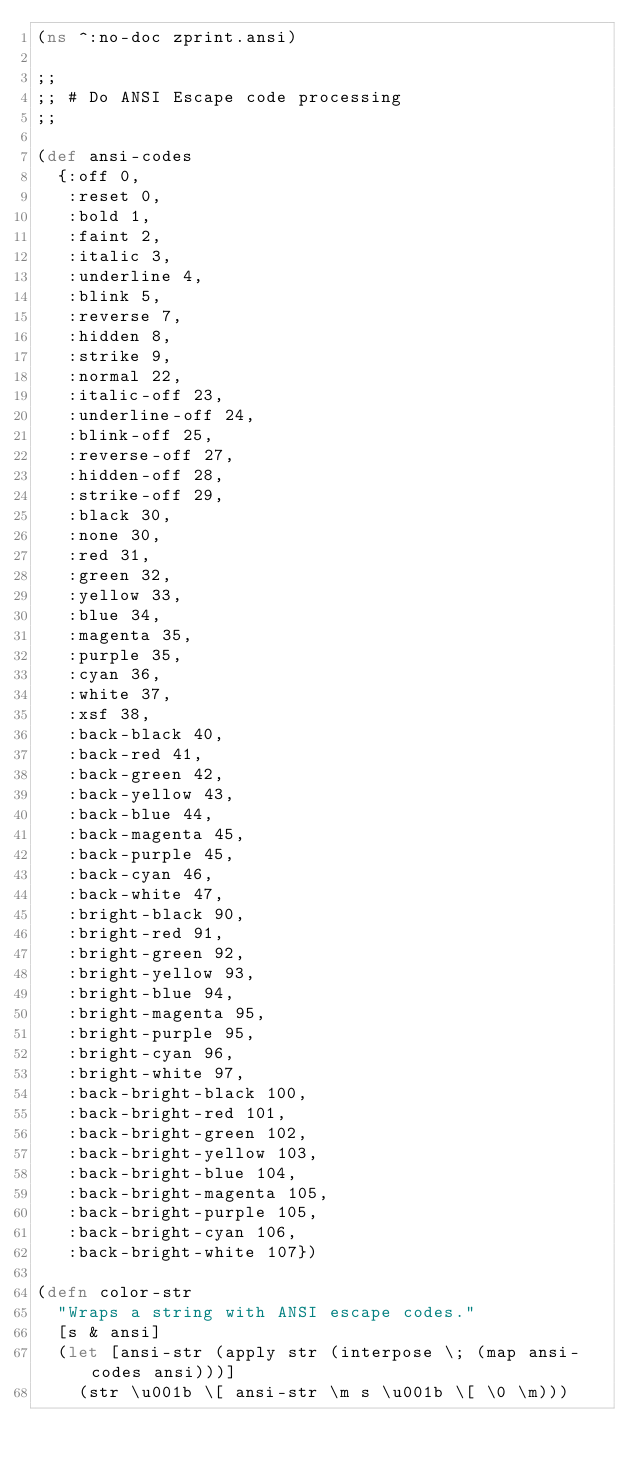Convert code to text. <code><loc_0><loc_0><loc_500><loc_500><_Clojure_>(ns ^:no-doc zprint.ansi)

;;
;; # Do ANSI Escape code processing
;;

(def ansi-codes
  {:off 0,
   :reset 0,
   :bold 1,
   :faint 2,
   :italic 3,
   :underline 4,
   :blink 5,
   :reverse 7,
   :hidden 8,
   :strike 9,
   :normal 22,
   :italic-off 23,
   :underline-off 24,
   :blink-off 25,
   :reverse-off 27,
   :hidden-off 28,
   :strike-off 29,
   :black 30,
   :none 30,
   :red 31,
   :green 32,
   :yellow 33,
   :blue 34,
   :magenta 35,
   :purple 35,
   :cyan 36,
   :white 37,
   :xsf 38,
   :back-black 40,
   :back-red 41,
   :back-green 42,
   :back-yellow 43,
   :back-blue 44,
   :back-magenta 45,
   :back-purple 45,
   :back-cyan 46,
   :back-white 47,
   :bright-black 90,
   :bright-red 91,
   :bright-green 92,
   :bright-yellow 93,
   :bright-blue 94,
   :bright-magenta 95,
   :bright-purple 95,
   :bright-cyan 96,
   :bright-white 97,
   :back-bright-black 100,
   :back-bright-red 101,
   :back-bright-green 102,
   :back-bright-yellow 103,
   :back-bright-blue 104,
   :back-bright-magenta 105,
   :back-bright-purple 105,
   :back-bright-cyan 106,
   :back-bright-white 107})

(defn color-str
  "Wraps a string with ANSI escape codes."
  [s & ansi]
  (let [ansi-str (apply str (interpose \; (map ansi-codes ansi)))]
    (str \u001b \[ ansi-str \m s \u001b \[ \0 \m)))</code> 